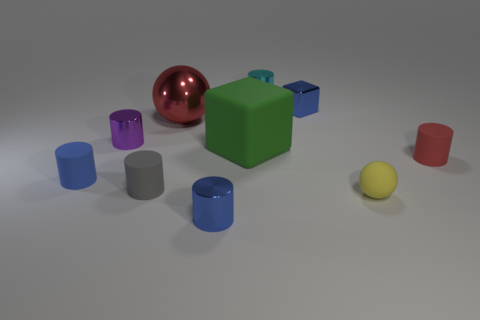Subtract 3 cylinders. How many cylinders are left? 3 Subtract all red cylinders. How many cylinders are left? 5 Subtract all tiny blue cylinders. How many cylinders are left? 4 Subtract all yellow cylinders. Subtract all gray cubes. How many cylinders are left? 6 Subtract all cylinders. How many objects are left? 4 Add 9 tiny red matte objects. How many tiny red matte objects exist? 10 Subtract 1 red spheres. How many objects are left? 9 Subtract all small blue metallic spheres. Subtract all metallic cylinders. How many objects are left? 7 Add 2 cyan objects. How many cyan objects are left? 3 